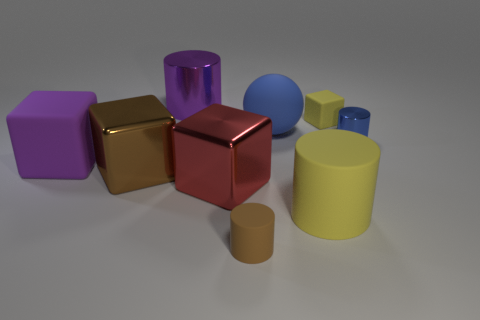Subtract 2 cylinders. How many cylinders are left? 2 Subtract all big blocks. How many blocks are left? 1 Subtract all brown cylinders. How many cylinders are left? 3 Add 1 red matte cylinders. How many objects exist? 10 Subtract all blue cubes. Subtract all gray cylinders. How many cubes are left? 4 Subtract all blocks. How many objects are left? 5 Add 4 small blue cylinders. How many small blue cylinders exist? 5 Subtract 0 cyan cubes. How many objects are left? 9 Subtract all cyan cylinders. Subtract all brown cubes. How many objects are left? 8 Add 3 big brown things. How many big brown things are left? 4 